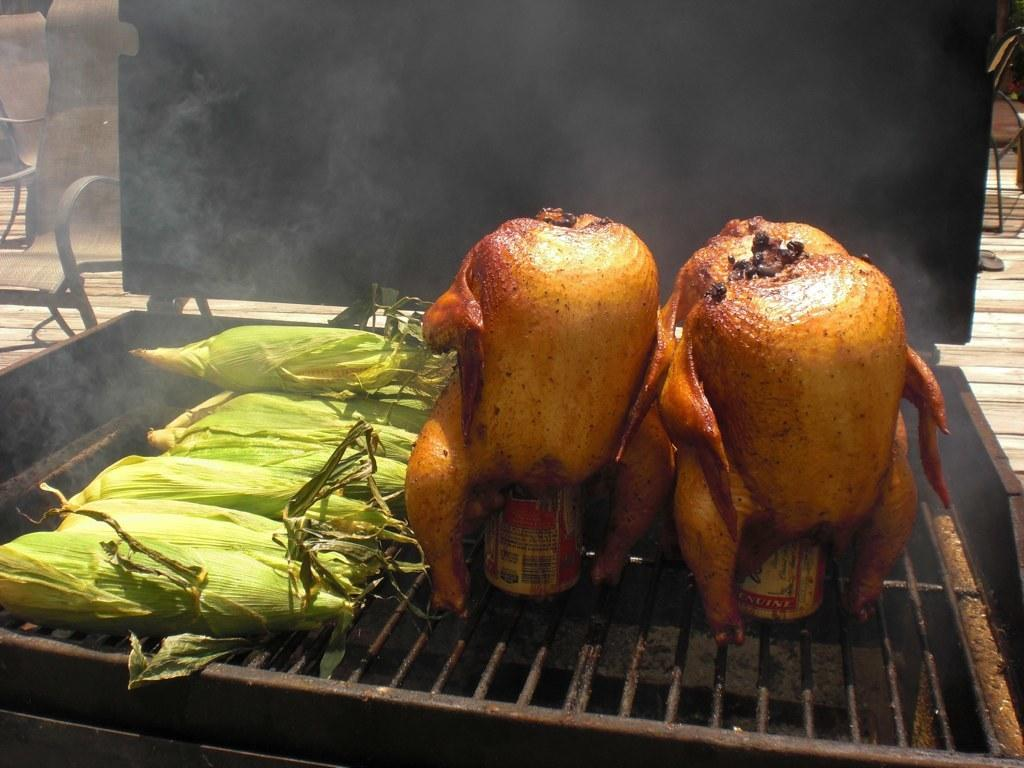What is the main subject of the image? The main subject of the image is mazes. Can you describe any other elements in the image? Yes, there is a "drunken chicken" on the net for grilling in the image. What can be seen in the background of the image? Chairs are visible in the background of the image. What type of boundary is present in the image? There is no boundary present in the image; it features mazes, a "drunken chicken" on the net for grilling, and chairs in the background. What kind of offer is being made in the image? There is no offer being made in the image; it is a picture of mazes, a "drunken chicken" on the net for grilling, and chairs in the background. 